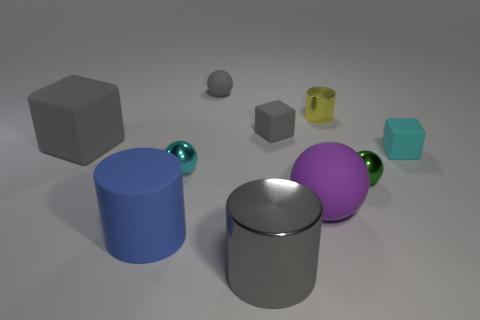Subtract 1 balls. How many balls are left? 3 Subtract all blue balls. Subtract all cyan cubes. How many balls are left? 4 Subtract all cylinders. How many objects are left? 7 Add 9 large blue cylinders. How many large blue cylinders exist? 10 Subtract 0 brown cubes. How many objects are left? 10 Subtract all purple metallic cylinders. Subtract all big rubber cubes. How many objects are left? 9 Add 4 tiny things. How many tiny things are left? 10 